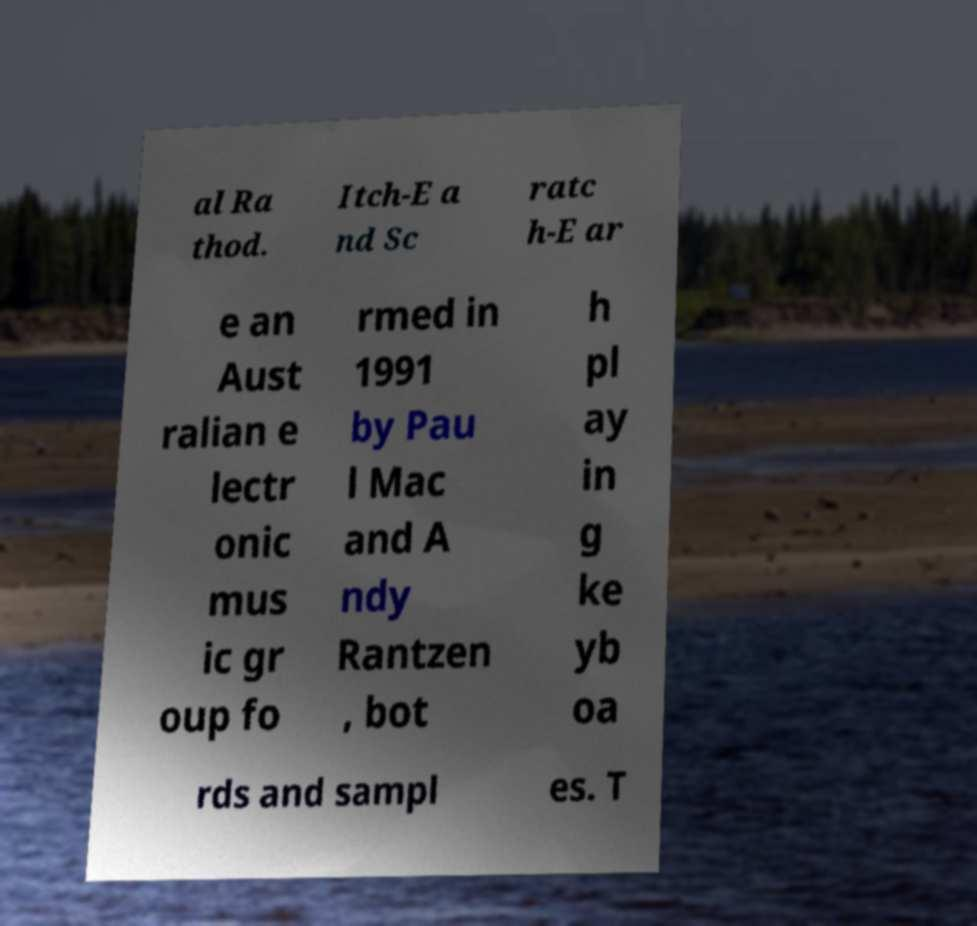Please read and relay the text visible in this image. What does it say? al Ra thod. Itch-E a nd Sc ratc h-E ar e an Aust ralian e lectr onic mus ic gr oup fo rmed in 1991 by Pau l Mac and A ndy Rantzen , bot h pl ay in g ke yb oa rds and sampl es. T 